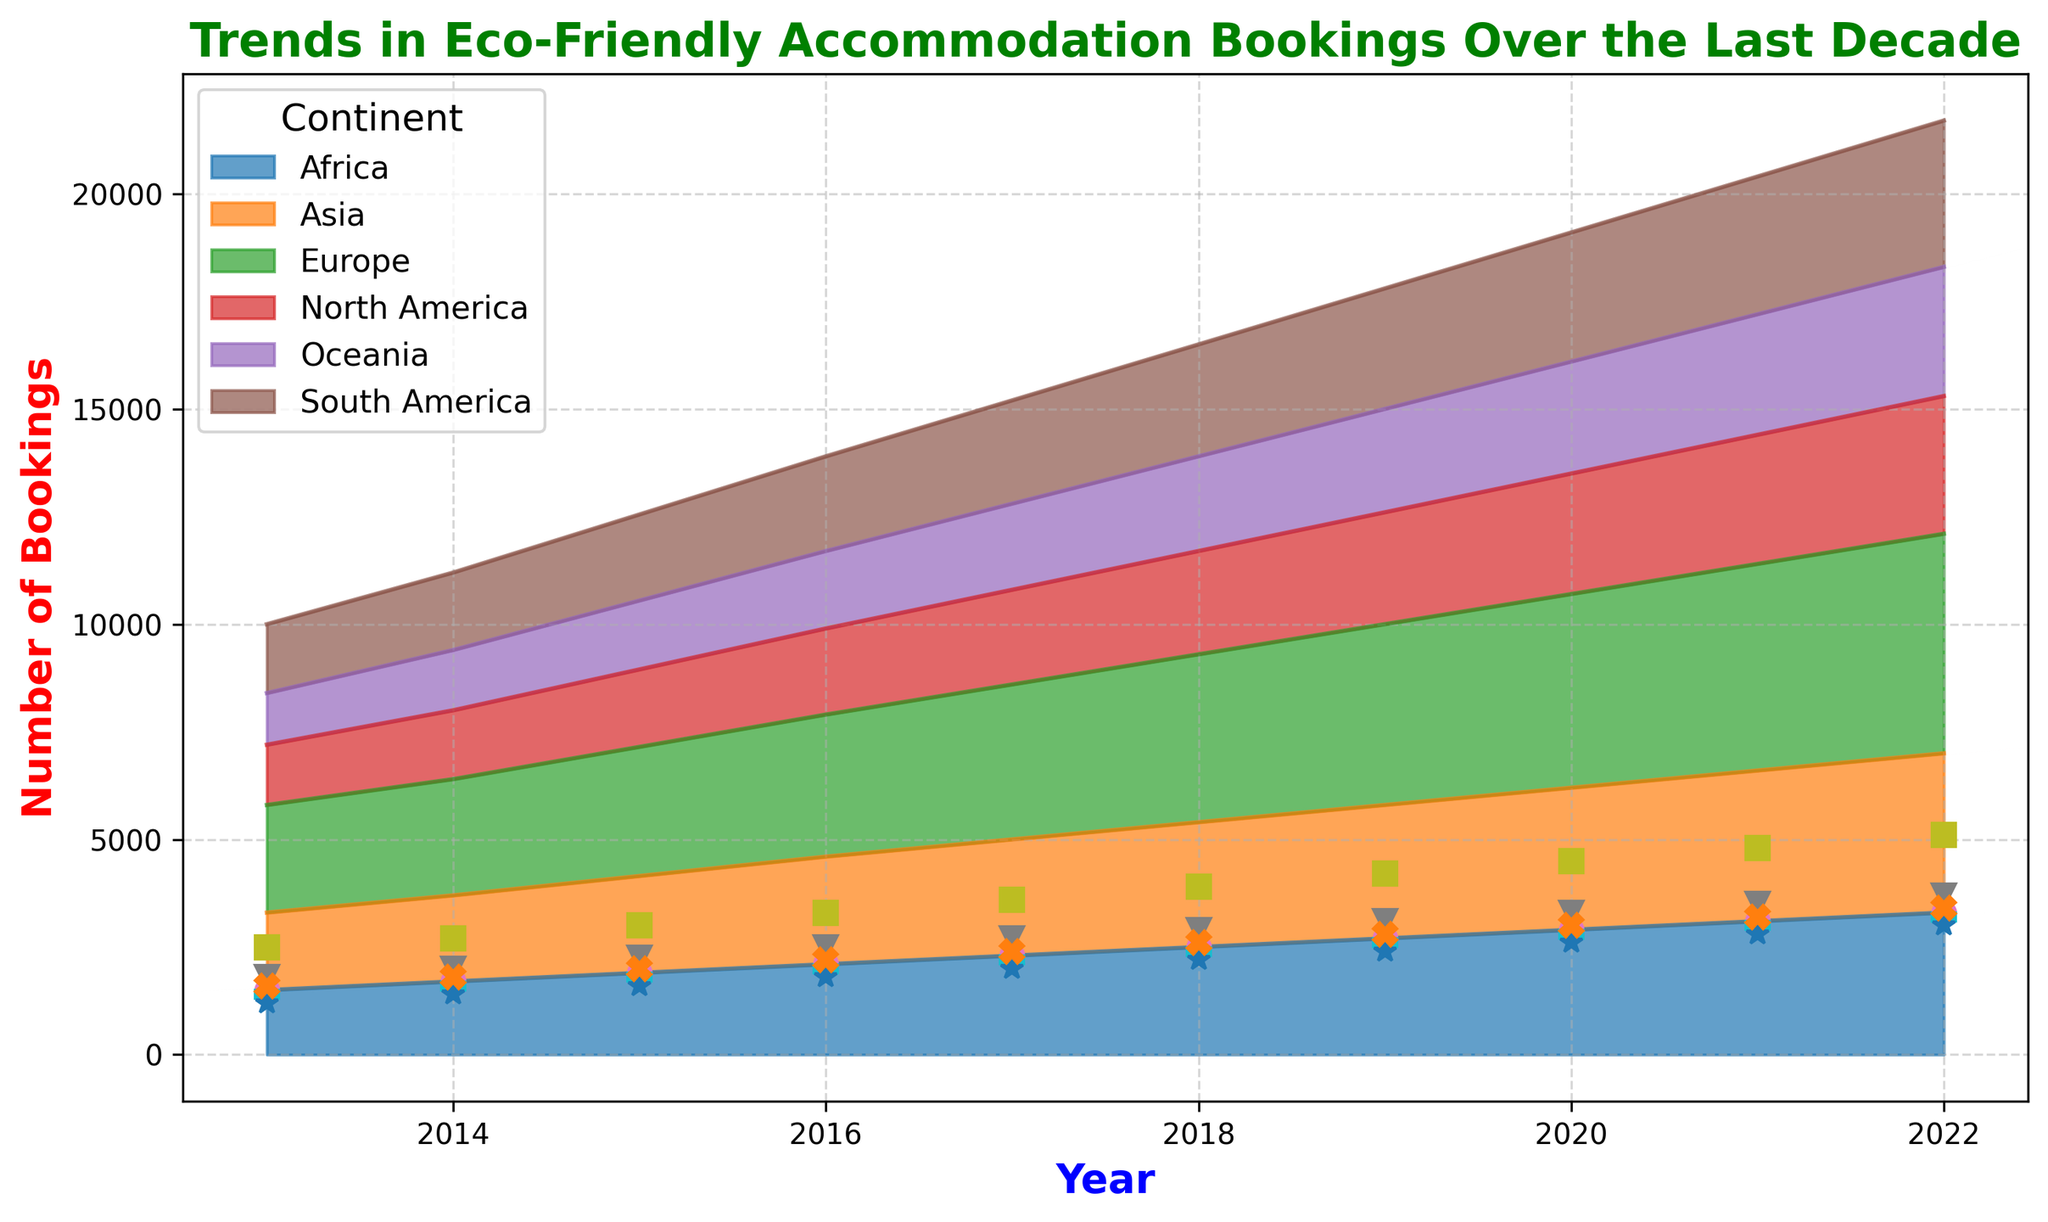Which continent saw the highest increase in eco-friendly accommodation bookings over the decade? To determine the highest increase, calculate the difference between the bookings in 2022 and 2013 for each continent. Europe goes from 2500 to 5100, which is an increase of 2600. This is the highest among all continents.
Answer: Europe Which year did North America have at least 3000 eco-friendly accommodation bookings for the first time? By looking at the trend line for North America, we see that the first year it reached at least 3000 bookings was 2021.
Answer: 2021 Among Africa, Asia, and Oceania, which continent had the lowest number of bookings in 2013? Compare the values for Africa, Asia, and Oceania in 2013: Africa (1500), Asia (1800), Oceania (1200). Oceania has the lowest number of bookings.
Answer: Oceania How many more eco-friendly bookings did Europe have than North America in 2022? Subtract the number of bookings in North America from Europe in 2022: 5100 (Europe) - 3200 (North America) = 1900.
Answer: 1900 What is the average number of eco-friendly accommodation bookings in Asia over the decade? Sum the bookings for Asia from 2013 to 2022 and divide by the number of years: (1800 + 2000 + 2250 + 2500 + 2700 + 2900 + 3100 + 3300 + 3500 + 3700) / 10 = 2775.
Answer: 2775 Did South America or Oceania experience a higher relative increase in bookings from 2013 to 2022? Calculate the relative increase for each: South America (3400 - 1600) / 1600 = 1.125, Oceania (3000 - 1200) / 1200 = 1.5. Oceania's relative increase is higher.
Answer: Oceania In which year did the combined bookings for Africa and South America surpass 4000 for the first time? Add bookings for Africa and South America for each year until the sum goes above 4000. In 2014: Africa (1700) + South America (1800) = 3500; in 2015: Africa (1900) + South America (2000) = 3900; in 2016: Africa (2100) + South America (2200) = 4300. Therefore, the first year is 2016.
Answer: 2016 Which continent had the steadiest growth in eco-friendly accommodation bookings from 2013 to 2022? A visual inspection shows that Africa has a very steady upward trend without abrupt changes, indicating steady growth.
Answer: Africa 